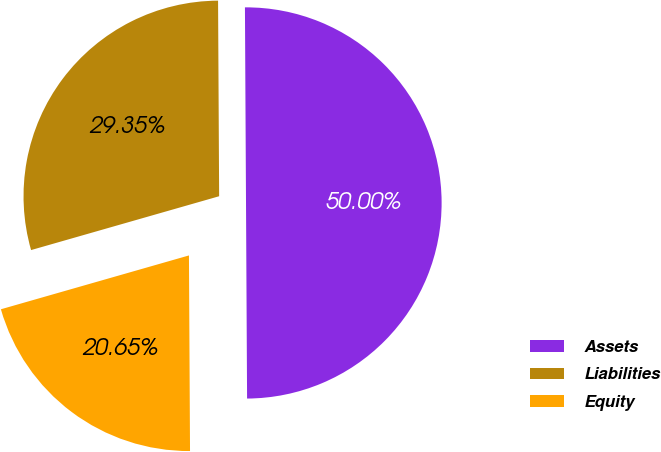Convert chart. <chart><loc_0><loc_0><loc_500><loc_500><pie_chart><fcel>Assets<fcel>Liabilities<fcel>Equity<nl><fcel>50.0%<fcel>29.35%<fcel>20.65%<nl></chart> 